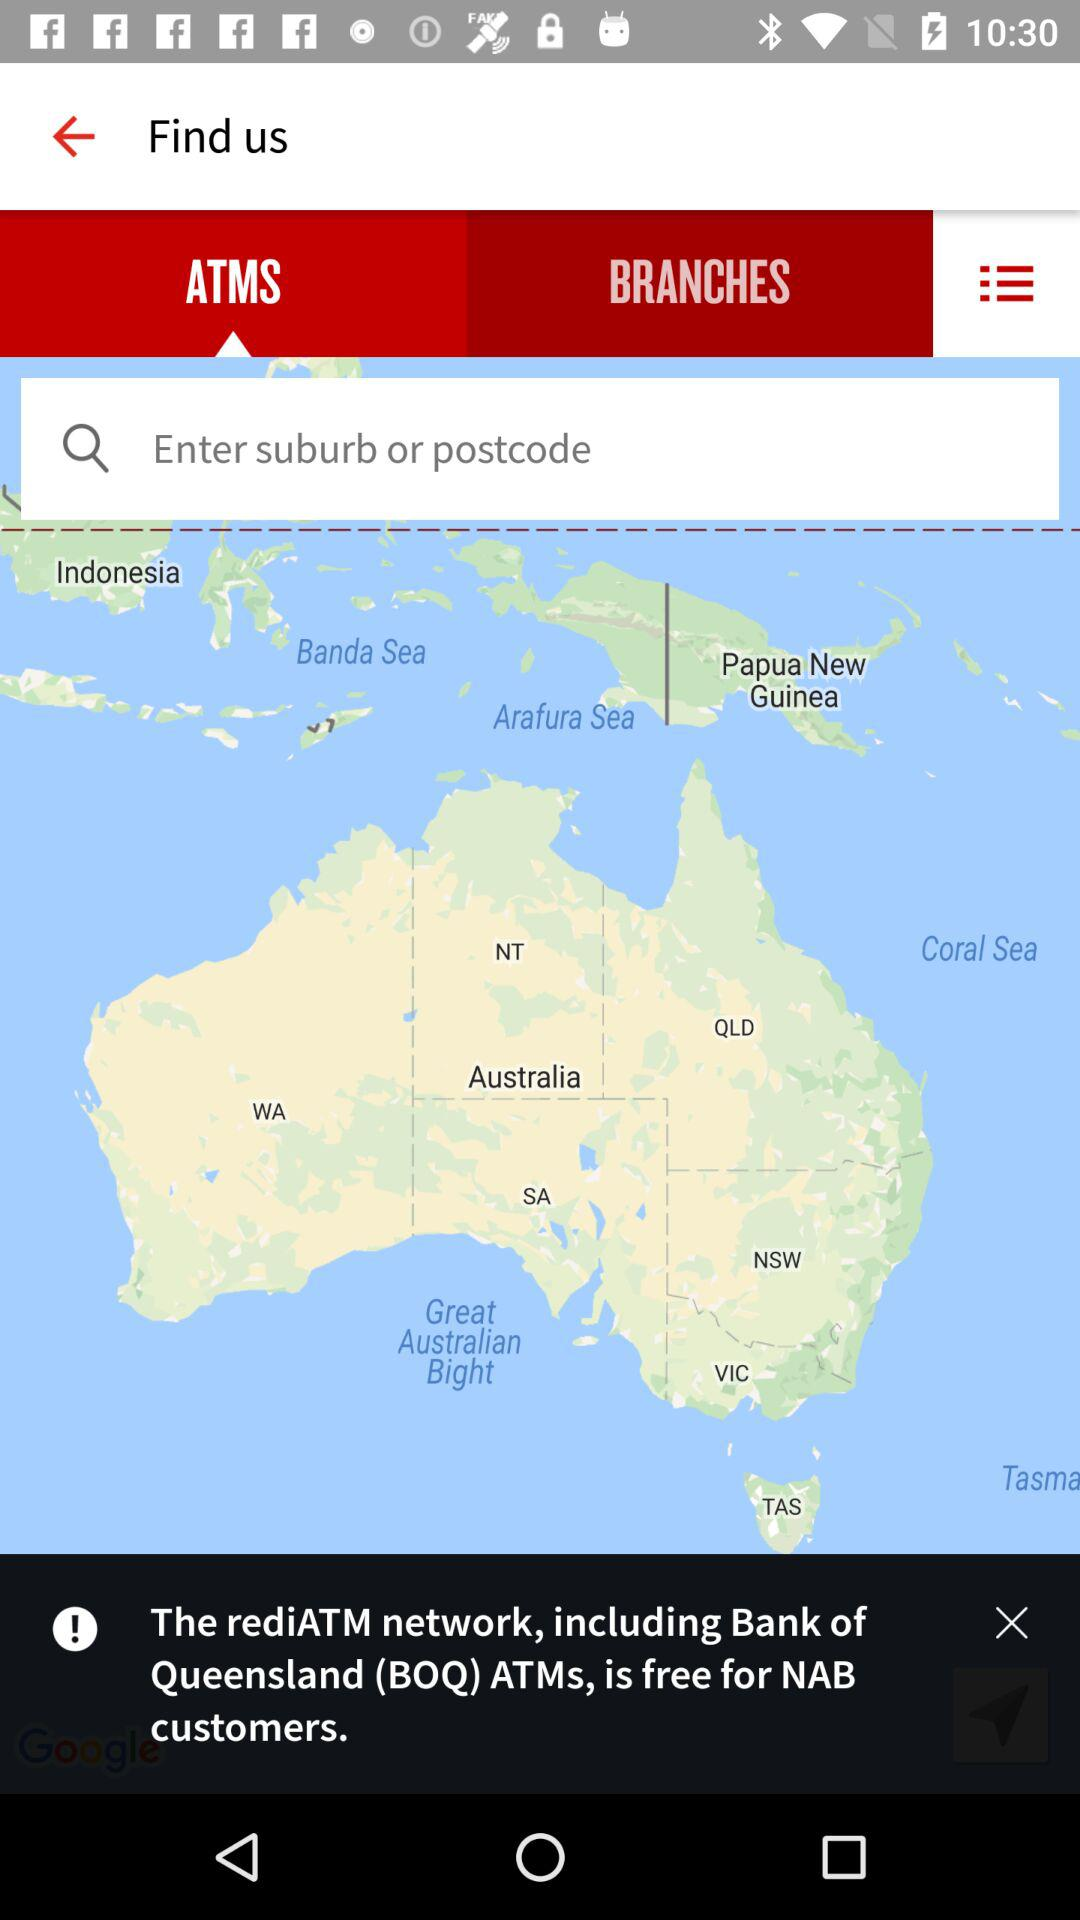What is the name of the network that is free for NAB customers? The name of the network is "rediATM". 